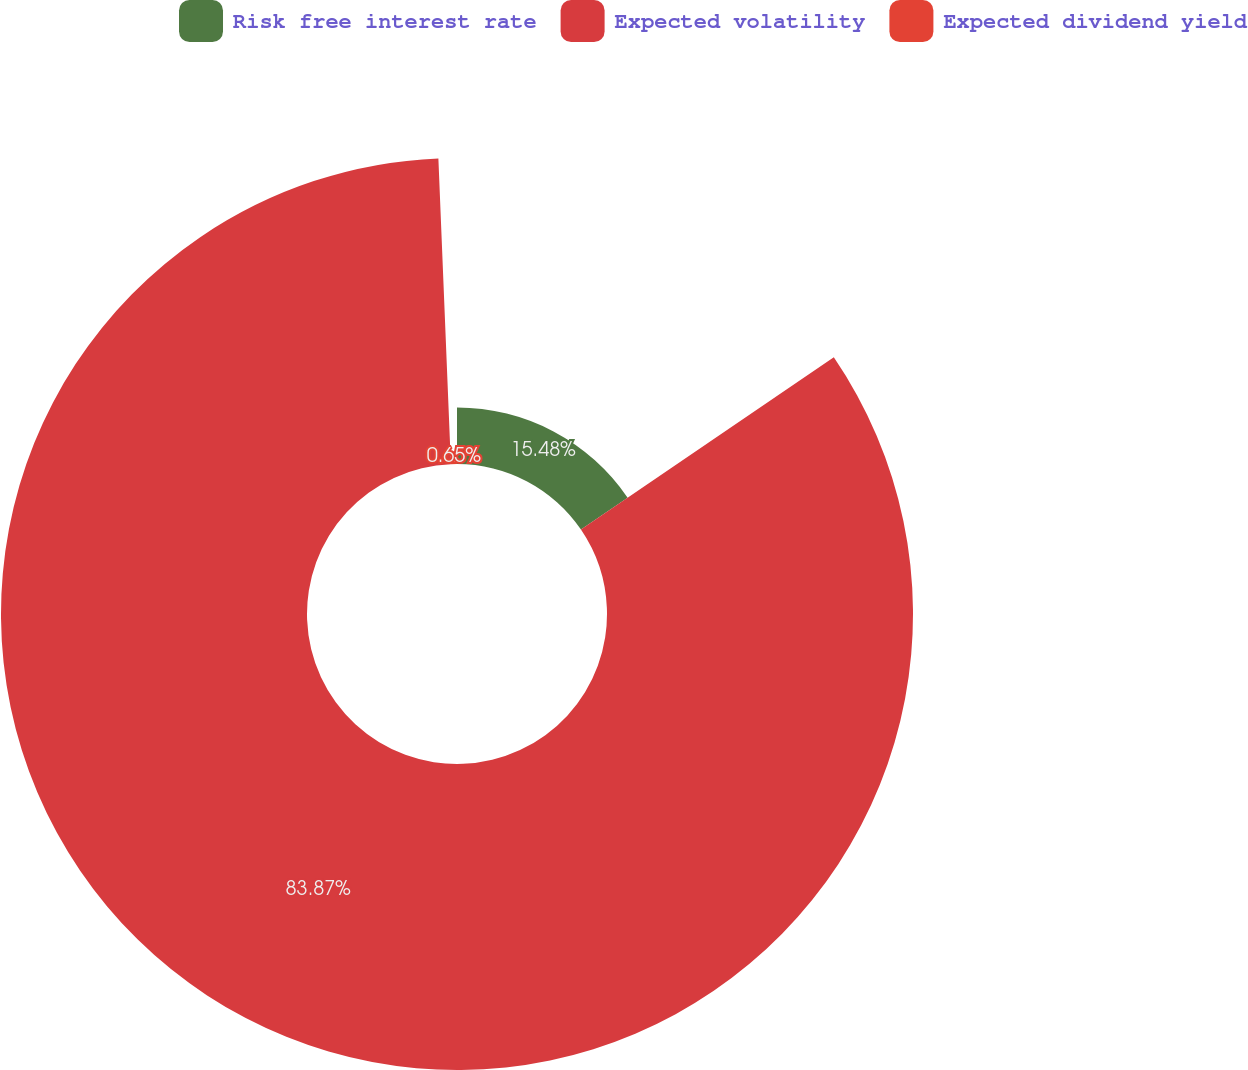Convert chart. <chart><loc_0><loc_0><loc_500><loc_500><pie_chart><fcel>Risk free interest rate<fcel>Expected volatility<fcel>Expected dividend yield<nl><fcel>15.48%<fcel>83.87%<fcel>0.65%<nl></chart> 